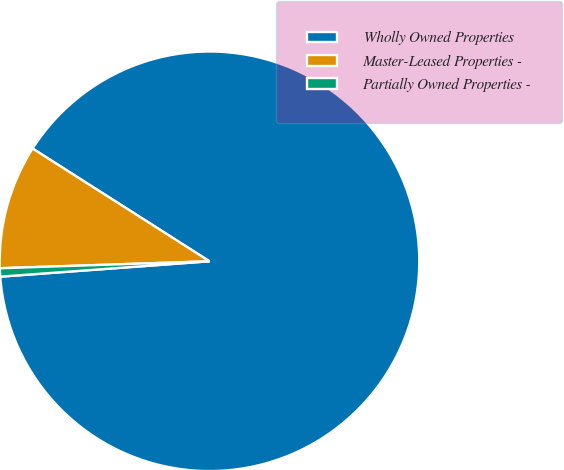Convert chart to OTSL. <chart><loc_0><loc_0><loc_500><loc_500><pie_chart><fcel>Wholly Owned Properties<fcel>Master-Leased Properties -<fcel>Partially Owned Properties -<nl><fcel>89.8%<fcel>9.56%<fcel>0.64%<nl></chart> 